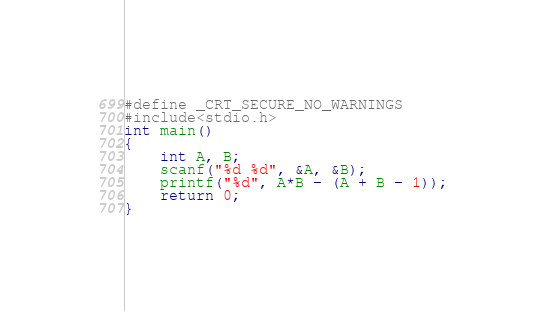<code> <loc_0><loc_0><loc_500><loc_500><_C_>#define _CRT_SECURE_NO_WARNINGS
#include<stdio.h>
int main()
{
	int A, B;
	scanf("%d %d", &A, &B);
	printf("%d", A*B - (A + B - 1));
	return 0;
}</code> 